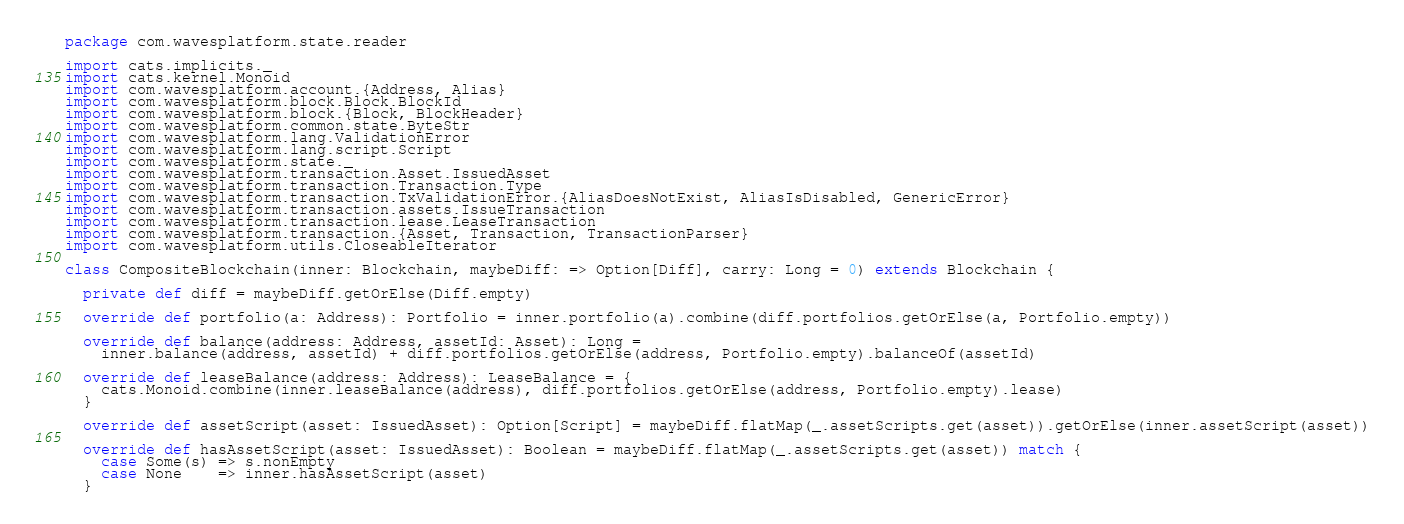Convert code to text. <code><loc_0><loc_0><loc_500><loc_500><_Scala_>package com.wavesplatform.state.reader

import cats.implicits._
import cats.kernel.Monoid
import com.wavesplatform.account.{Address, Alias}
import com.wavesplatform.block.Block.BlockId
import com.wavesplatform.block.{Block, BlockHeader}
import com.wavesplatform.common.state.ByteStr
import com.wavesplatform.lang.ValidationError
import com.wavesplatform.lang.script.Script
import com.wavesplatform.state._
import com.wavesplatform.transaction.Asset.IssuedAsset
import com.wavesplatform.transaction.Transaction.Type
import com.wavesplatform.transaction.TxValidationError.{AliasDoesNotExist, AliasIsDisabled, GenericError}
import com.wavesplatform.transaction.assets.IssueTransaction
import com.wavesplatform.transaction.lease.LeaseTransaction
import com.wavesplatform.transaction.{Asset, Transaction, TransactionParser}
import com.wavesplatform.utils.CloseableIterator

class CompositeBlockchain(inner: Blockchain, maybeDiff: => Option[Diff], carry: Long = 0) extends Blockchain {

  private def diff = maybeDiff.getOrElse(Diff.empty)

  override def portfolio(a: Address): Portfolio = inner.portfolio(a).combine(diff.portfolios.getOrElse(a, Portfolio.empty))

  override def balance(address: Address, assetId: Asset): Long =
    inner.balance(address, assetId) + diff.portfolios.getOrElse(address, Portfolio.empty).balanceOf(assetId)

  override def leaseBalance(address: Address): LeaseBalance = {
    cats.Monoid.combine(inner.leaseBalance(address), diff.portfolios.getOrElse(address, Portfolio.empty).lease)
  }

  override def assetScript(asset: IssuedAsset): Option[Script] = maybeDiff.flatMap(_.assetScripts.get(asset)).getOrElse(inner.assetScript(asset))

  override def hasAssetScript(asset: IssuedAsset): Boolean = maybeDiff.flatMap(_.assetScripts.get(asset)) match {
    case Some(s) => s.nonEmpty
    case None    => inner.hasAssetScript(asset)
  }
</code> 